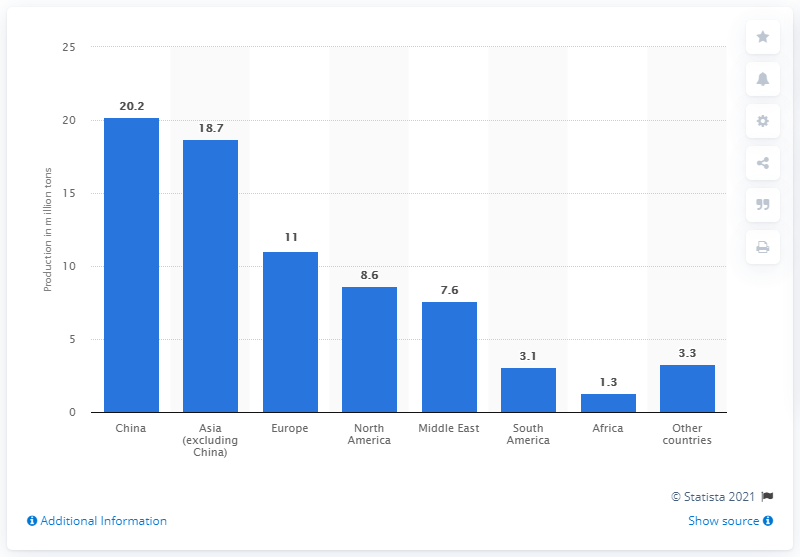Identify some key points in this picture. In 2016, the production of polypropylene in China was 20.2 million metric tons. 